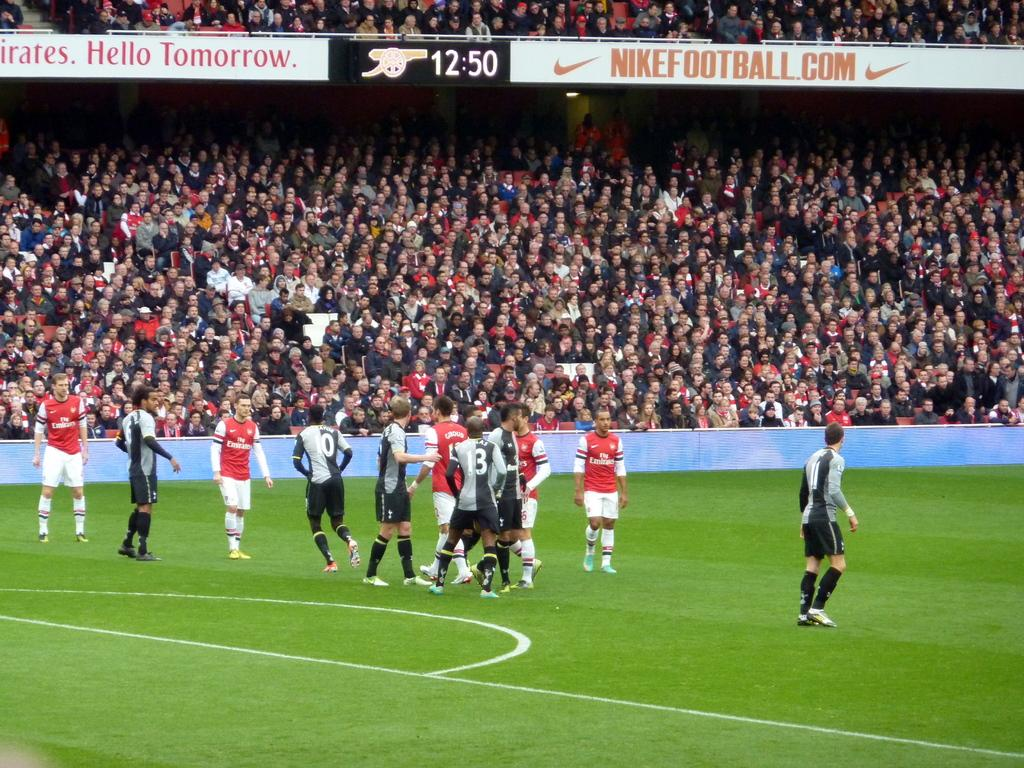<image>
Write a terse but informative summary of the picture. Soccer stadium that says "Nikefootball" on top and the time 12:50. 